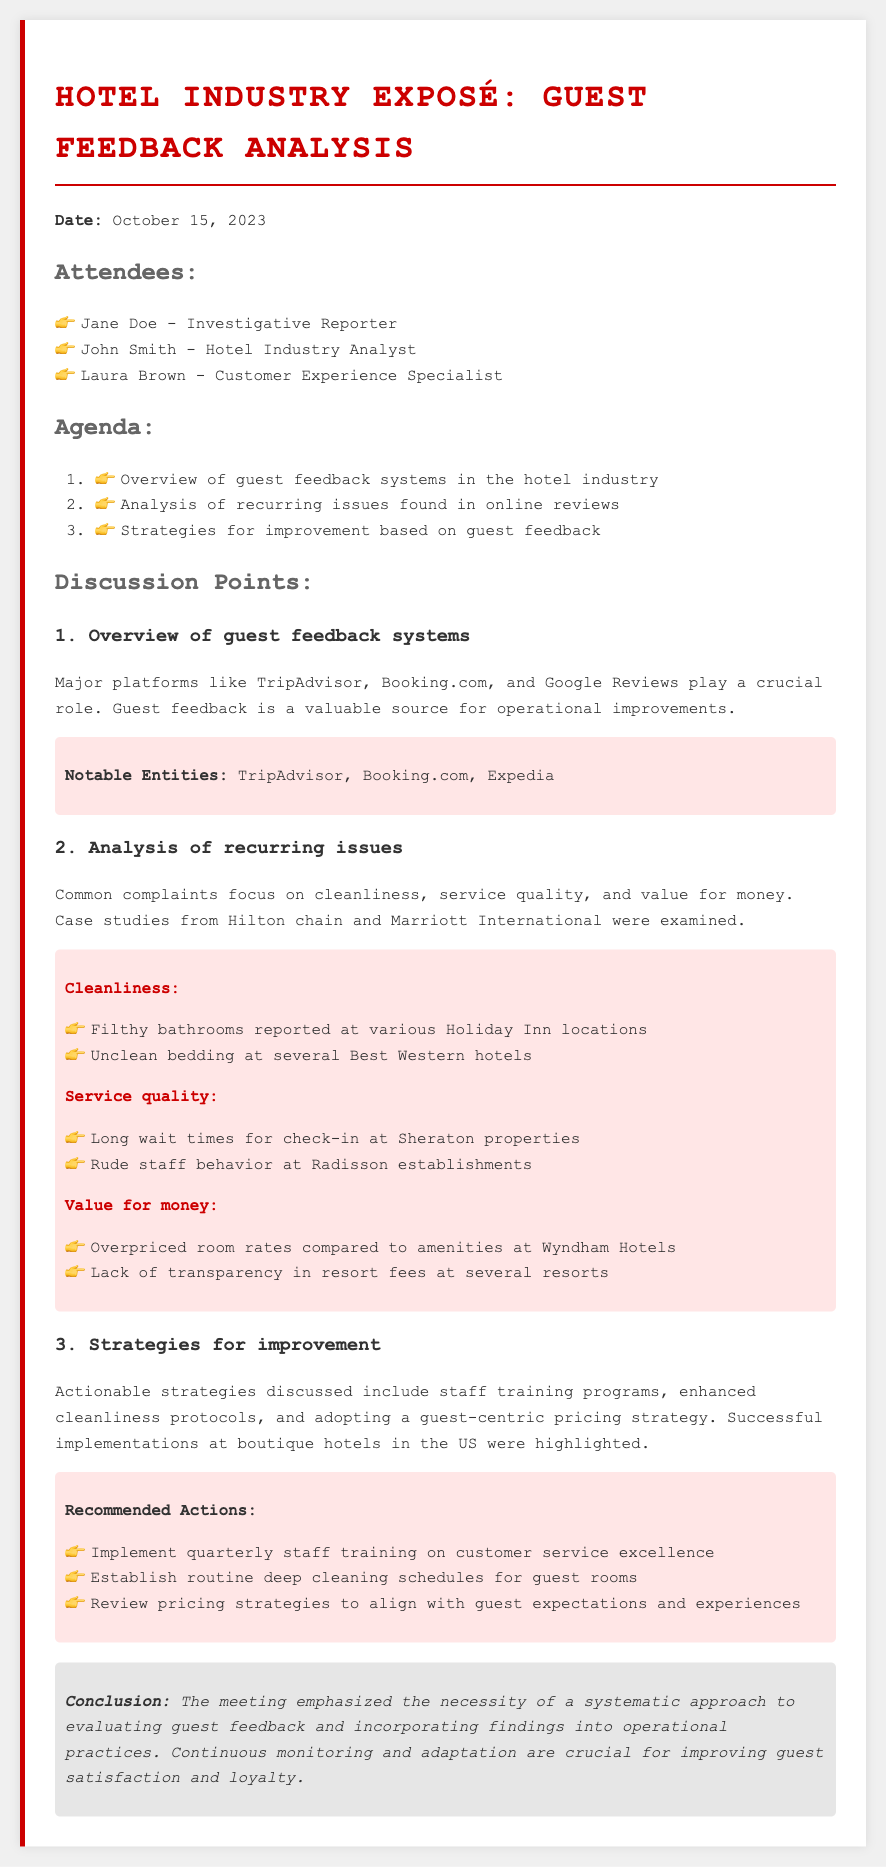what is the date of the meeting? The date of the meeting is explicitly stated in the document as October 15, 2023.
Answer: October 15, 2023 who is the customer experience specialist present at the meeting? The document lists Laura Brown as the customer experience specialist in the attendees section.
Answer: Laura Brown which platforms are mentioned as major guest feedback systems? The document specifies TripAdvisor, Booking.com, and Google Reviews as significant platforms for guest feedback.
Answer: TripAdvisor, Booking.com, Google Reviews what is one recurring issue related to cleanliness mentioned in the analysis? The document highlights filthy bathrooms reported at various Holiday Inn locations as a cleanliness issue.
Answer: Filthy bathrooms what strategies for improvement were recommended? The document outlines several recommended actions, including implementing quarterly staff training on customer service excellence.
Answer: Quarterly staff training how many key issues were discussed in the analysis section? The document identifies three key issue categories: cleanliness, service quality, and value for money, thus totaling three issues.
Answer: Three what was emphasized in the conclusion of the meeting? The conclusion highlights the importance of a systematic approach to evaluating guest feedback and incorporating findings into operational practices.
Answer: Systematic approach which hotel chain was mentioned that had long wait times for check-in? Sheraton properties were specifically mentioned in relation to long wait times for check-in in the analysis of recurring issues.
Answer: Sheraton what specific aspect of hotel management does 'value for money' pertain to? The document explains it pertains to the perception of pricing versus amenities provided across various hotels.
Answer: Pricing versus amenities 